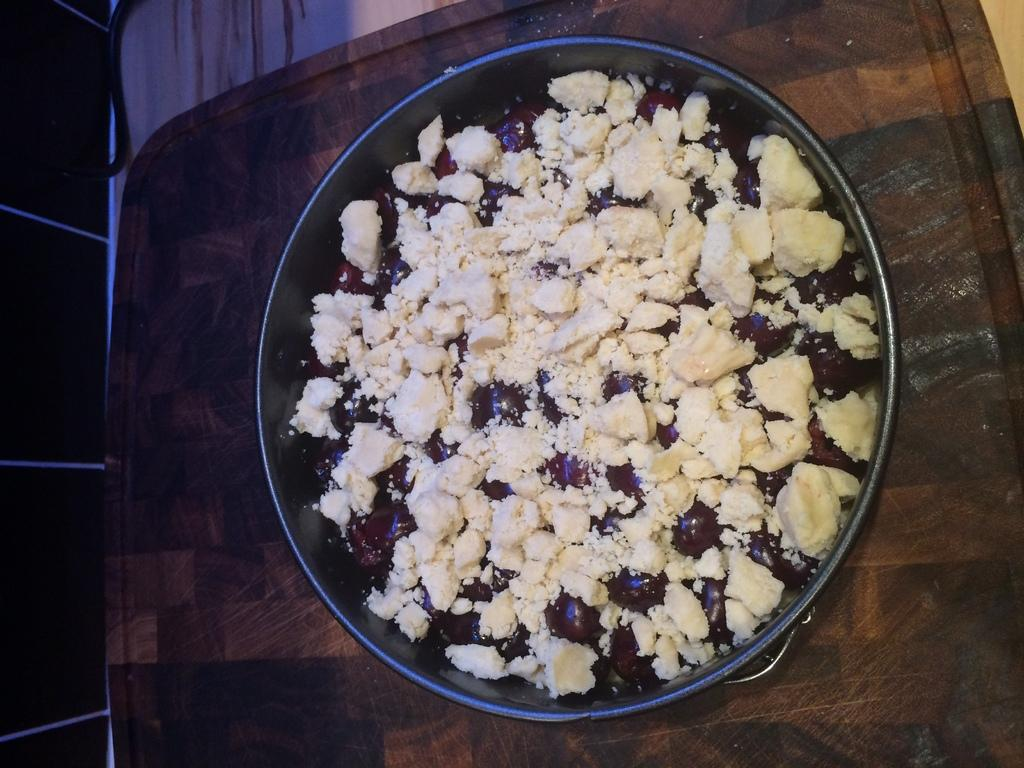What is in the pan that is visible in the image? There is food in a pan in the image. Where is the pan located in the image? The pan is placed on a table. What type of necklace is the achiever wearing in the image? There is no achiever or necklace present in the image; it only features a pan with food on a table. 